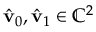Convert formula to latex. <formula><loc_0><loc_0><loc_500><loc_500>\hat { v } _ { 0 } , \hat { v } _ { 1 } \in \mathbb { C } ^ { 2 }</formula> 